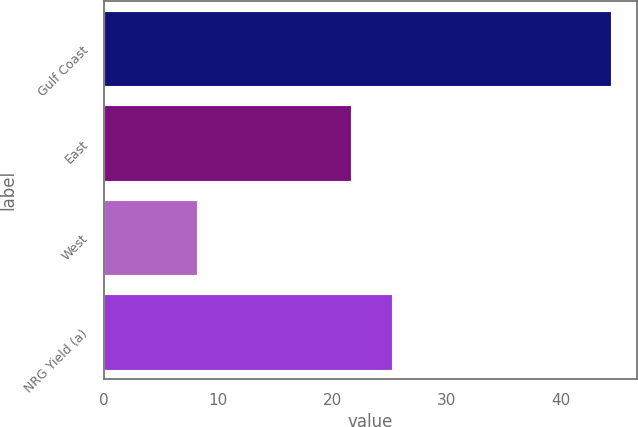<chart> <loc_0><loc_0><loc_500><loc_500><bar_chart><fcel>Gulf Coast<fcel>East<fcel>West<fcel>NRG Yield (a)<nl><fcel>44.4<fcel>21.6<fcel>8.1<fcel>25.23<nl></chart> 